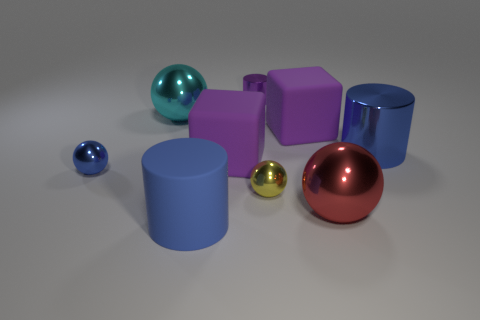Subtract all big red spheres. How many spheres are left? 3 Add 1 tiny gray cubes. How many objects exist? 10 Subtract 4 balls. How many balls are left? 0 Subtract all cylinders. How many objects are left? 6 Subtract all tiny blue metallic objects. Subtract all tiny blue metal balls. How many objects are left? 7 Add 8 yellow spheres. How many yellow spheres are left? 9 Add 2 big cyan balls. How many big cyan balls exist? 3 Subtract all cyan balls. How many balls are left? 3 Subtract 0 brown blocks. How many objects are left? 9 Subtract all green cylinders. Subtract all brown spheres. How many cylinders are left? 3 